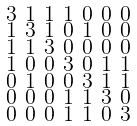<formula> <loc_0><loc_0><loc_500><loc_500>\begin{smallmatrix} 3 & 1 & 1 & 1 & 0 & 0 & 0 \\ 1 & 3 & 1 & 0 & 1 & 0 & 0 \\ 1 & 1 & 3 & 0 & 0 & 0 & 0 \\ 1 & 0 & 0 & 3 & 0 & 1 & 1 \\ 0 & 1 & 0 & 0 & 3 & 1 & 1 \\ 0 & 0 & 0 & 1 & 1 & 3 & 0 \\ 0 & 0 & 0 & 1 & 1 & 0 & 3 \end{smallmatrix}</formula> 